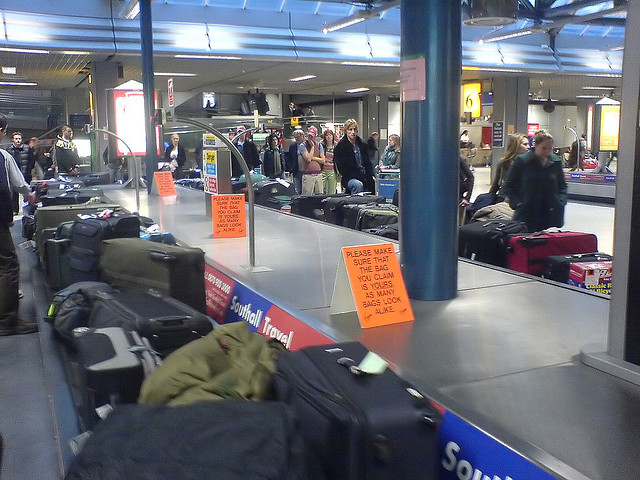Please identify all text content in this image. Southall Travel PLEASE MAKE SURE THAT THE Sou ALAKE LOOK MANY AS YOURS IS CLAM YOU BAG 